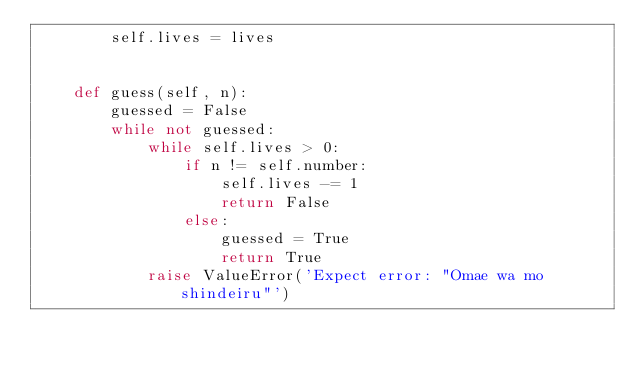Convert code to text. <code><loc_0><loc_0><loc_500><loc_500><_Python_>        self.lives = lives


    def guess(self, n):
        guessed = False
        while not guessed:
            while self.lives > 0:
                if n != self.number:
                    self.lives -= 1
                    return False
                else:
                    guessed = True
                    return True
            raise ValueError('Expect error: "Omae wa mo shindeiru"')
</code> 